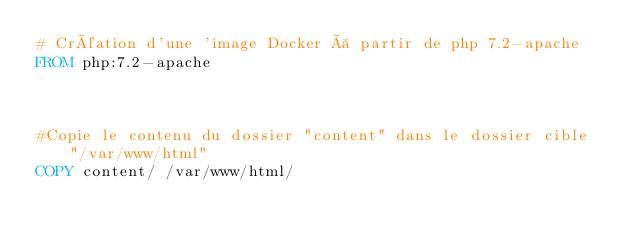<code> <loc_0><loc_0><loc_500><loc_500><_Dockerfile_># Création d'une 'image Docker à partir de php 7.2-apache
FROM php:7.2-apache



#Copie le contenu du dossier "content" dans le dossier cible "/var/www/html" 
COPY content/ /var/www/html/







</code> 